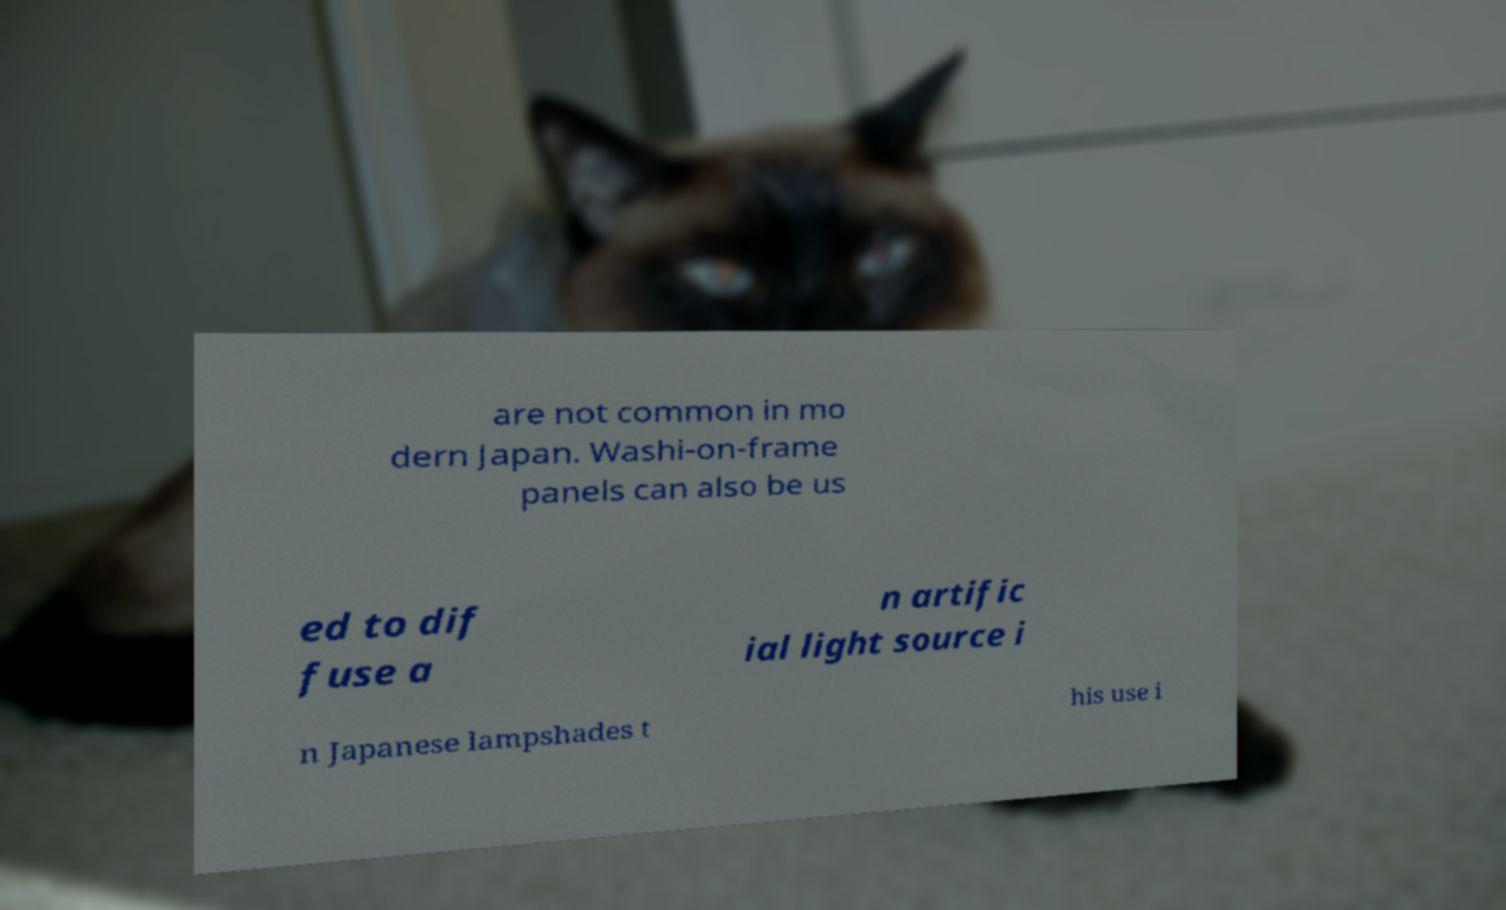For documentation purposes, I need the text within this image transcribed. Could you provide that? are not common in mo dern Japan. Washi-on-frame panels can also be us ed to dif fuse a n artific ial light source i n Japanese lampshades t his use i 